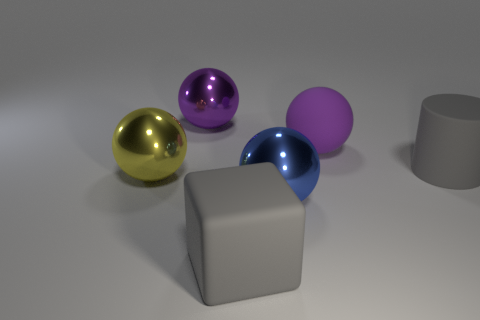Subtract all matte balls. How many balls are left? 3 Subtract 1 balls. How many balls are left? 3 Add 4 big matte cubes. How many objects exist? 10 Subtract all yellow spheres. How many spheres are left? 3 Subtract all blocks. How many objects are left? 5 Add 4 metallic spheres. How many metallic spheres exist? 7 Subtract 1 gray cylinders. How many objects are left? 5 Subtract all blue spheres. Subtract all yellow cylinders. How many spheres are left? 3 Subtract all brown spheres. How many purple cylinders are left? 0 Subtract all brown blocks. Subtract all big yellow shiny spheres. How many objects are left? 5 